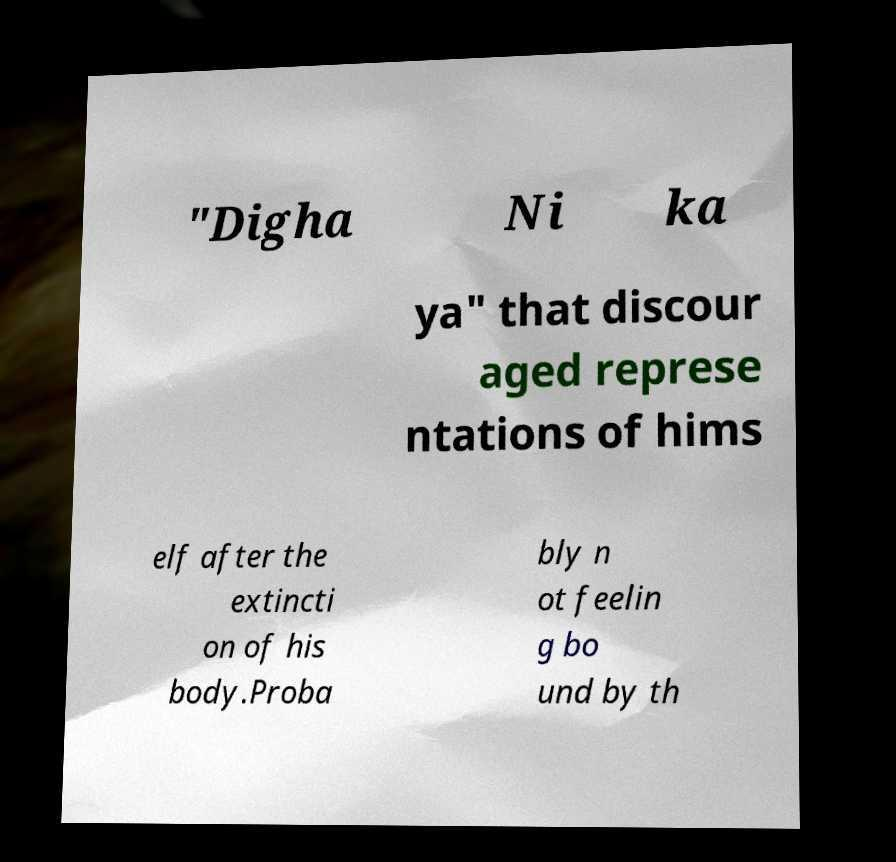What messages or text are displayed in this image? I need them in a readable, typed format. "Digha Ni ka ya" that discour aged represe ntations of hims elf after the extincti on of his body.Proba bly n ot feelin g bo und by th 